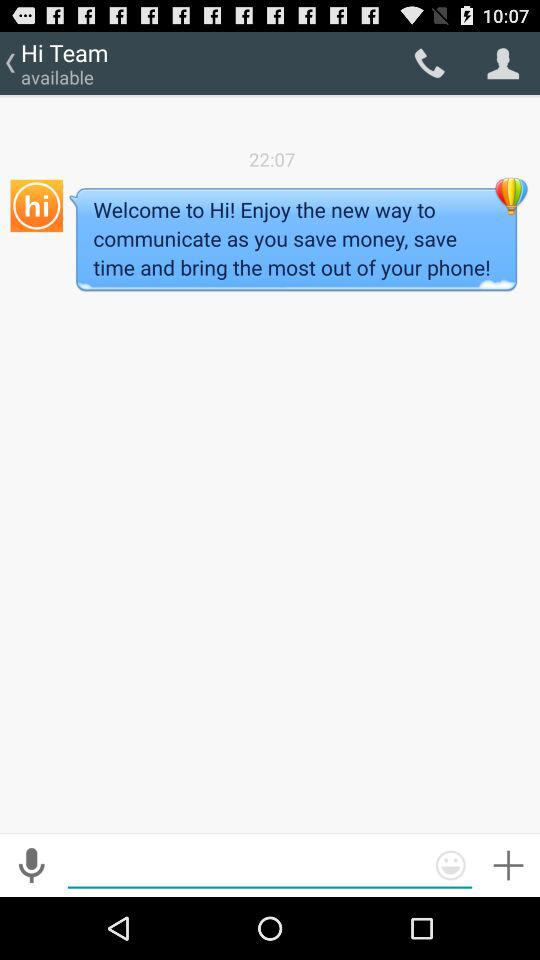What is the time of the message? The time of the message is 22:07. 